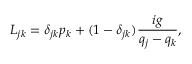<formula> <loc_0><loc_0><loc_500><loc_500>L _ { j k } = \delta _ { j k } p _ { k } + ( 1 - \delta _ { j k } ) \frac { i g } { q _ { j } - q _ { k } } ,</formula> 